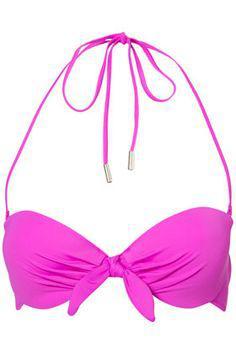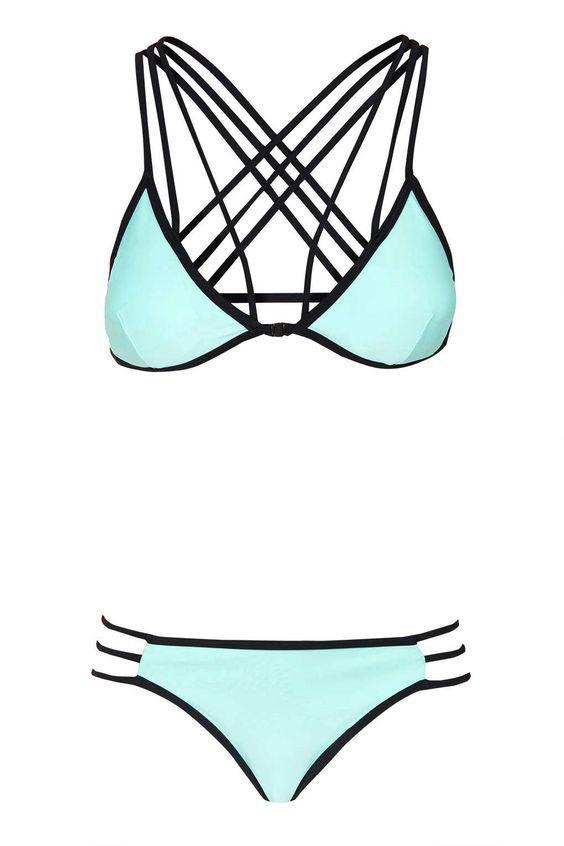The first image is the image on the left, the second image is the image on the right. For the images displayed, is the sentence "Only the right image shows a bikini top and bottom." factually correct? Answer yes or no. Yes. 